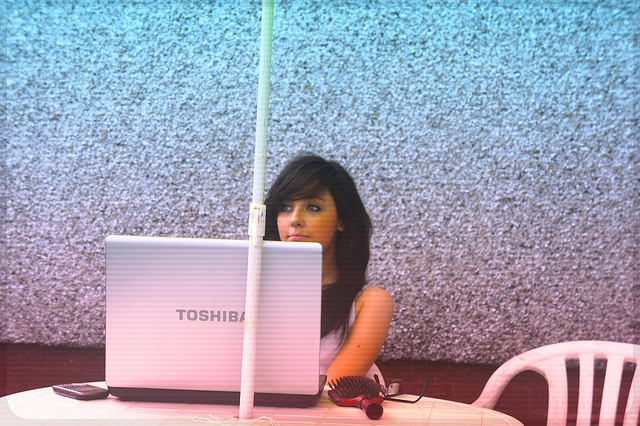Describe the objects in this image and their specific colors. I can see laptop in lightblue, pink, lightpink, and darkgray tones, people in lightblue, black, maroon, salmon, and brown tones, chair in lightblue, pink, brown, and lightpink tones, dining table in lightblue, white, lightpink, maroon, and pink tones, and cell phone in lightblue, brown, and gray tones in this image. 